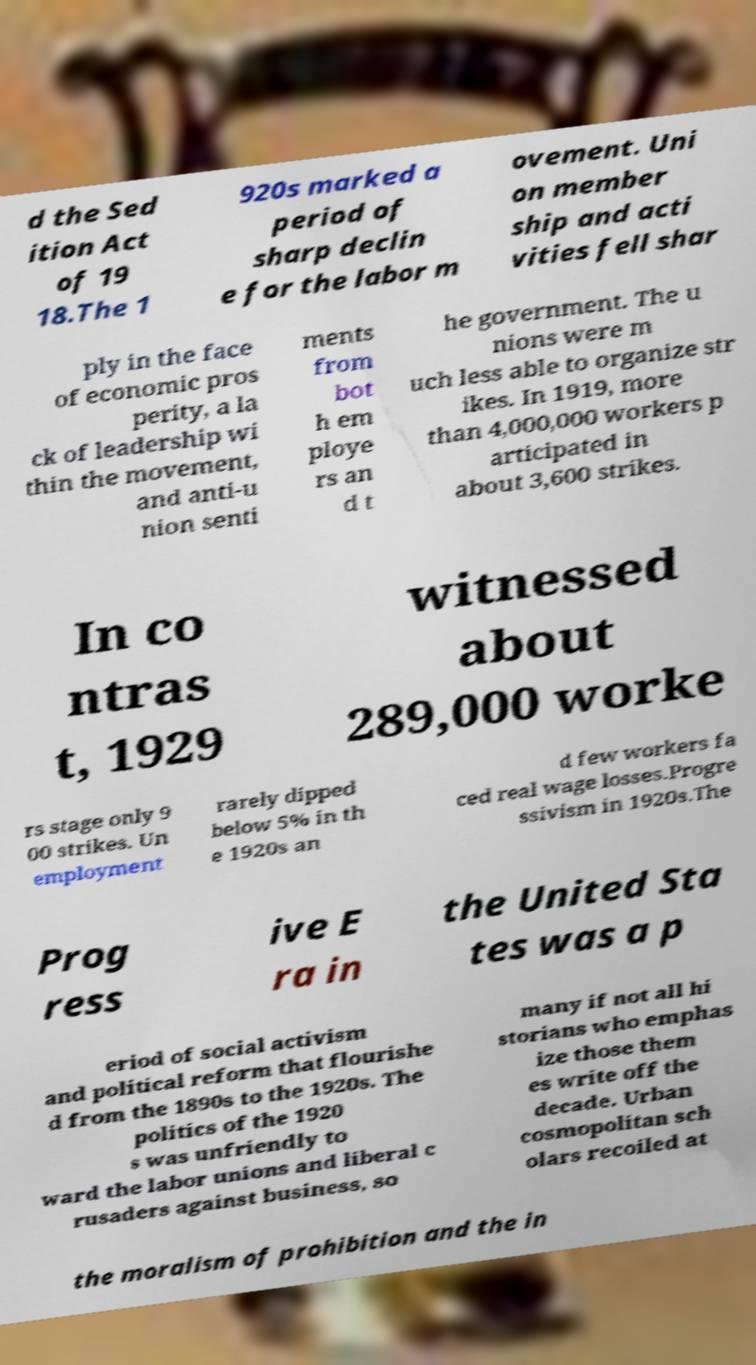For documentation purposes, I need the text within this image transcribed. Could you provide that? d the Sed ition Act of 19 18.The 1 920s marked a period of sharp declin e for the labor m ovement. Uni on member ship and acti vities fell shar ply in the face of economic pros perity, a la ck of leadership wi thin the movement, and anti-u nion senti ments from bot h em ploye rs an d t he government. The u nions were m uch less able to organize str ikes. In 1919, more than 4,000,000 workers p articipated in about 3,600 strikes. In co ntras t, 1929 witnessed about 289,000 worke rs stage only 9 00 strikes. Un employment rarely dipped below 5% in th e 1920s an d few workers fa ced real wage losses.Progre ssivism in 1920s.The Prog ress ive E ra in the United Sta tes was a p eriod of social activism and political reform that flourishe d from the 1890s to the 1920s. The politics of the 1920 s was unfriendly to ward the labor unions and liberal c rusaders against business, so many if not all hi storians who emphas ize those them es write off the decade. Urban cosmopolitan sch olars recoiled at the moralism of prohibition and the in 